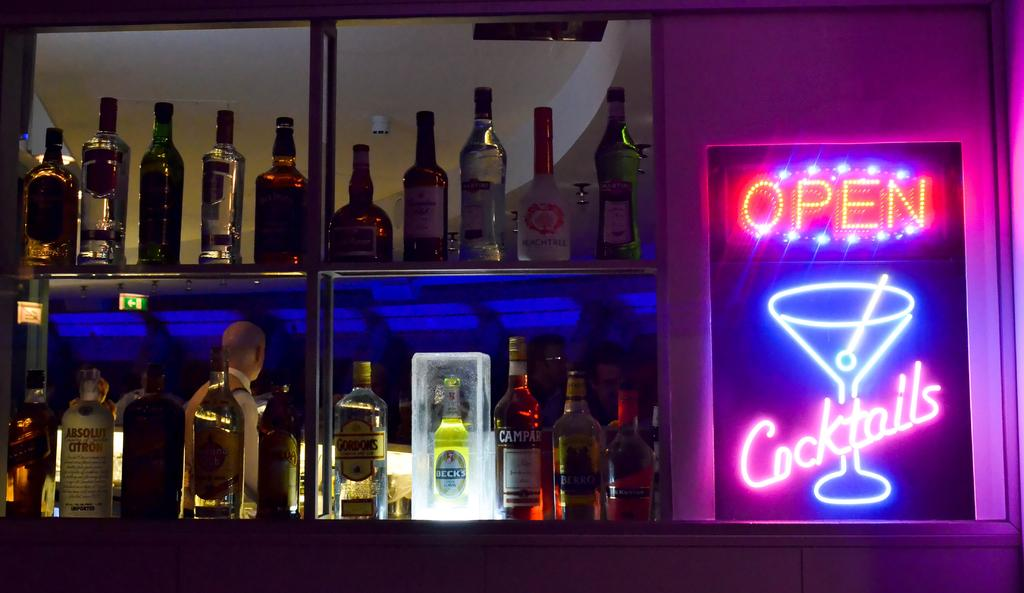Provide a one-sentence caption for the provided image. A bar has a neon sign next to it that says it is open for cocktails. 